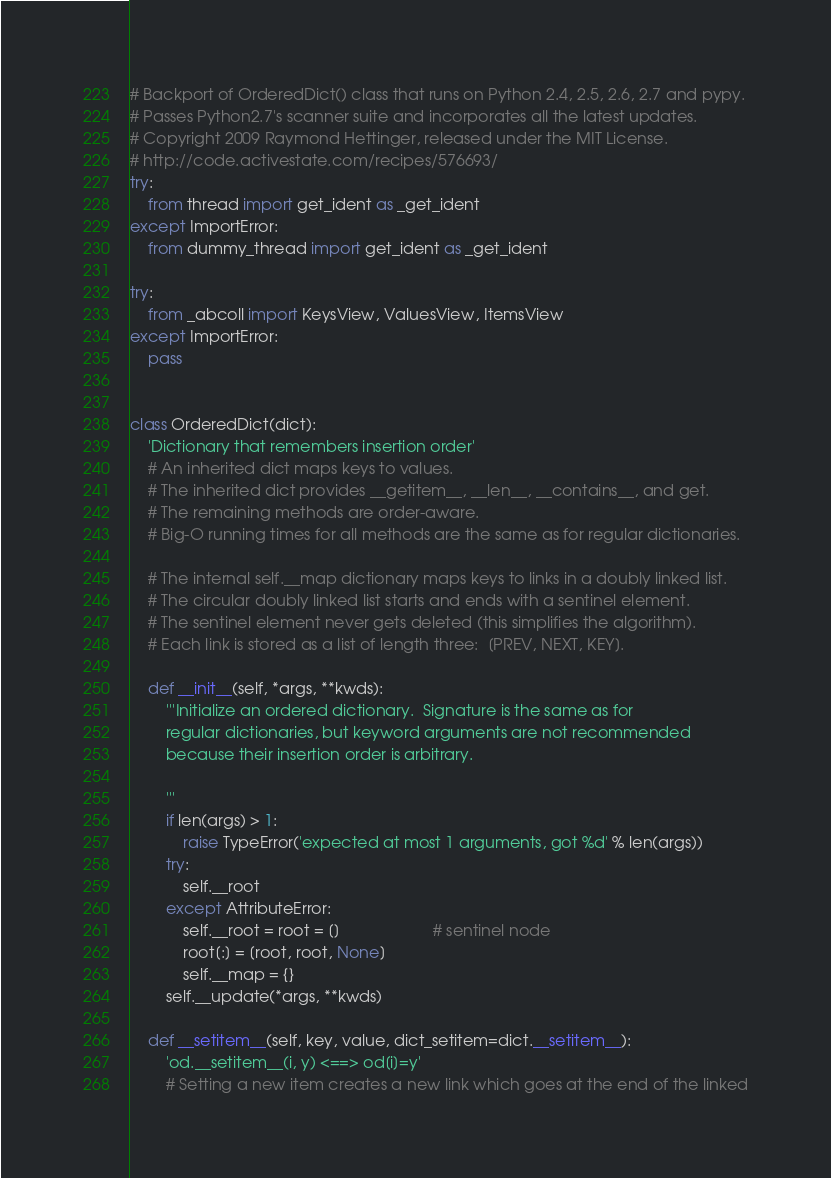<code> <loc_0><loc_0><loc_500><loc_500><_Python_># Backport of OrderedDict() class that runs on Python 2.4, 2.5, 2.6, 2.7 and pypy.
# Passes Python2.7's scanner suite and incorporates all the latest updates.
# Copyright 2009 Raymond Hettinger, released under the MIT License.
# http://code.activestate.com/recipes/576693/
try:
    from thread import get_ident as _get_ident
except ImportError:
    from dummy_thread import get_ident as _get_ident

try:
    from _abcoll import KeysView, ValuesView, ItemsView
except ImportError:
    pass


class OrderedDict(dict):
    'Dictionary that remembers insertion order'
    # An inherited dict maps keys to values.
    # The inherited dict provides __getitem__, __len__, __contains__, and get.
    # The remaining methods are order-aware.
    # Big-O running times for all methods are the same as for regular dictionaries.

    # The internal self.__map dictionary maps keys to links in a doubly linked list.
    # The circular doubly linked list starts and ends with a sentinel element.
    # The sentinel element never gets deleted (this simplifies the algorithm).
    # Each link is stored as a list of length three:  [PREV, NEXT, KEY].

    def __init__(self, *args, **kwds):
        '''Initialize an ordered dictionary.  Signature is the same as for
        regular dictionaries, but keyword arguments are not recommended
        because their insertion order is arbitrary.

        '''
        if len(args) > 1:
            raise TypeError('expected at most 1 arguments, got %d' % len(args))
        try:
            self.__root
        except AttributeError:
            self.__root = root = []                     # sentinel node
            root[:] = [root, root, None]
            self.__map = {}
        self.__update(*args, **kwds)

    def __setitem__(self, key, value, dict_setitem=dict.__setitem__):
        'od.__setitem__(i, y) <==> od[i]=y'
        # Setting a new item creates a new link which goes at the end of the linked</code> 